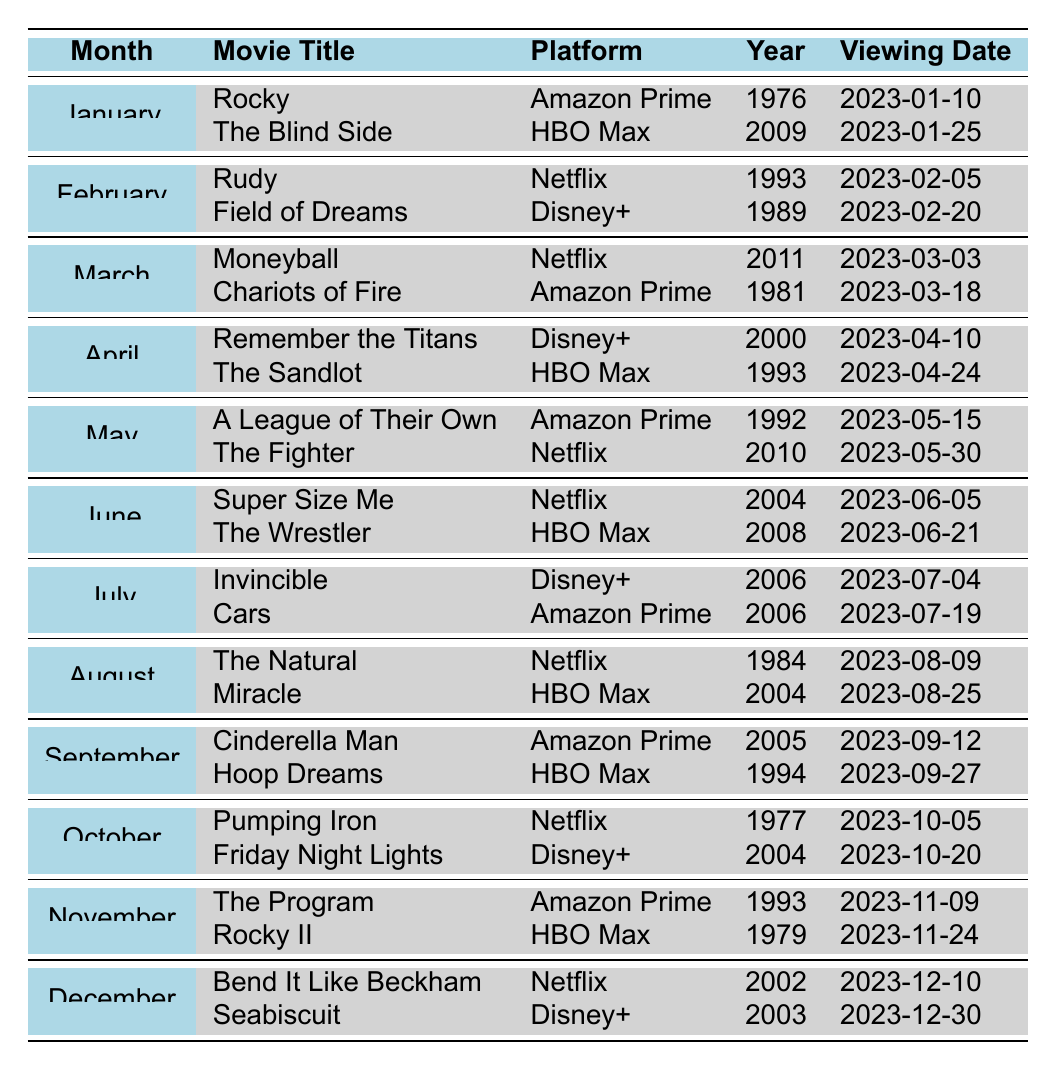What movies are being shown on Netflix in March? In March, the movies listed under Netflix are "Moneyball," which is a Biography/Drama/Sport released in 2011, and it is scheduled for viewing on March 3rd, and "Chariots of Fire," which is a Drama/Sport released in 1981, scheduled for March 18th.
Answer: Moneyball and Chariots of Fire How many classic sports movies are scheduled for viewing in August? There are 2 classic sports movies scheduled for viewing in August: "The Natural" and "Miracle."
Answer: 2 Is "Rocky II" available to watch on Disney+? "Rocky II" is available on HBO Max, not on Disney+, so the answer is false.
Answer: No Which platform features the movie "The Blind Side"? "The Blind Side" is available for viewing on HBO Max, as indicated in the January schedule.
Answer: HBO Max What is the release year of the oldest movie in the monthly viewing schedule? The oldest movie in the schedule is "Rocky," released in 1976, shown in January.
Answer: 1976 How many movies have a viewing date in the second half of the month across all months? By examining the schedule, the following movies are viewed in the second half: "The Sandlot" (April 24), "The Fighter" (May 30), "The Wrestler" (June 21), "Cars" (July 19), "Miracle" (August 25), "Hoop Dreams" (September 27), "Friday Night Lights" (October 20), "Rocky II" (November 24), and "Seabiscuit" (December 30). This gives a total of 9 movies.
Answer: 9 Which two months have the same genre of movies being shown? In February, "Rudy" and "Field of Dreams" are both Biography/Drama/Sport, while in April, "Remember the Titans" and "The Sandlot" represent Biography/Drama/Sport and Comedy/Family/Sport, respectively. The only matching genre is the presence of sports movies but with different specific genres. Thus, there are no months where the same genre is evident.
Answer: No matching genre List all movies scheduled for Netflix in December. In December, only "Bend It Like Beckham" is scheduled for viewing on Netflix, released in 2002 on December 10. "Seabiscuit" is on Disney+.
Answer: Bend It Like Beckham 